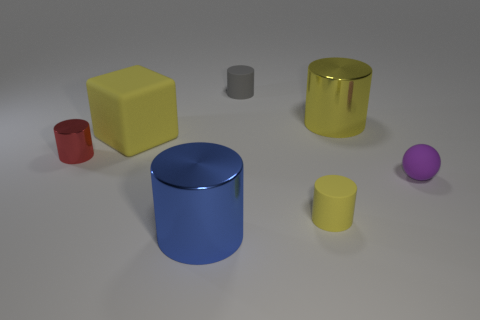How many other objects are there of the same shape as the blue object? Including the blue cylinder, there are two objects with cylindrical shapes. The other cylinder is smaller and grey. 